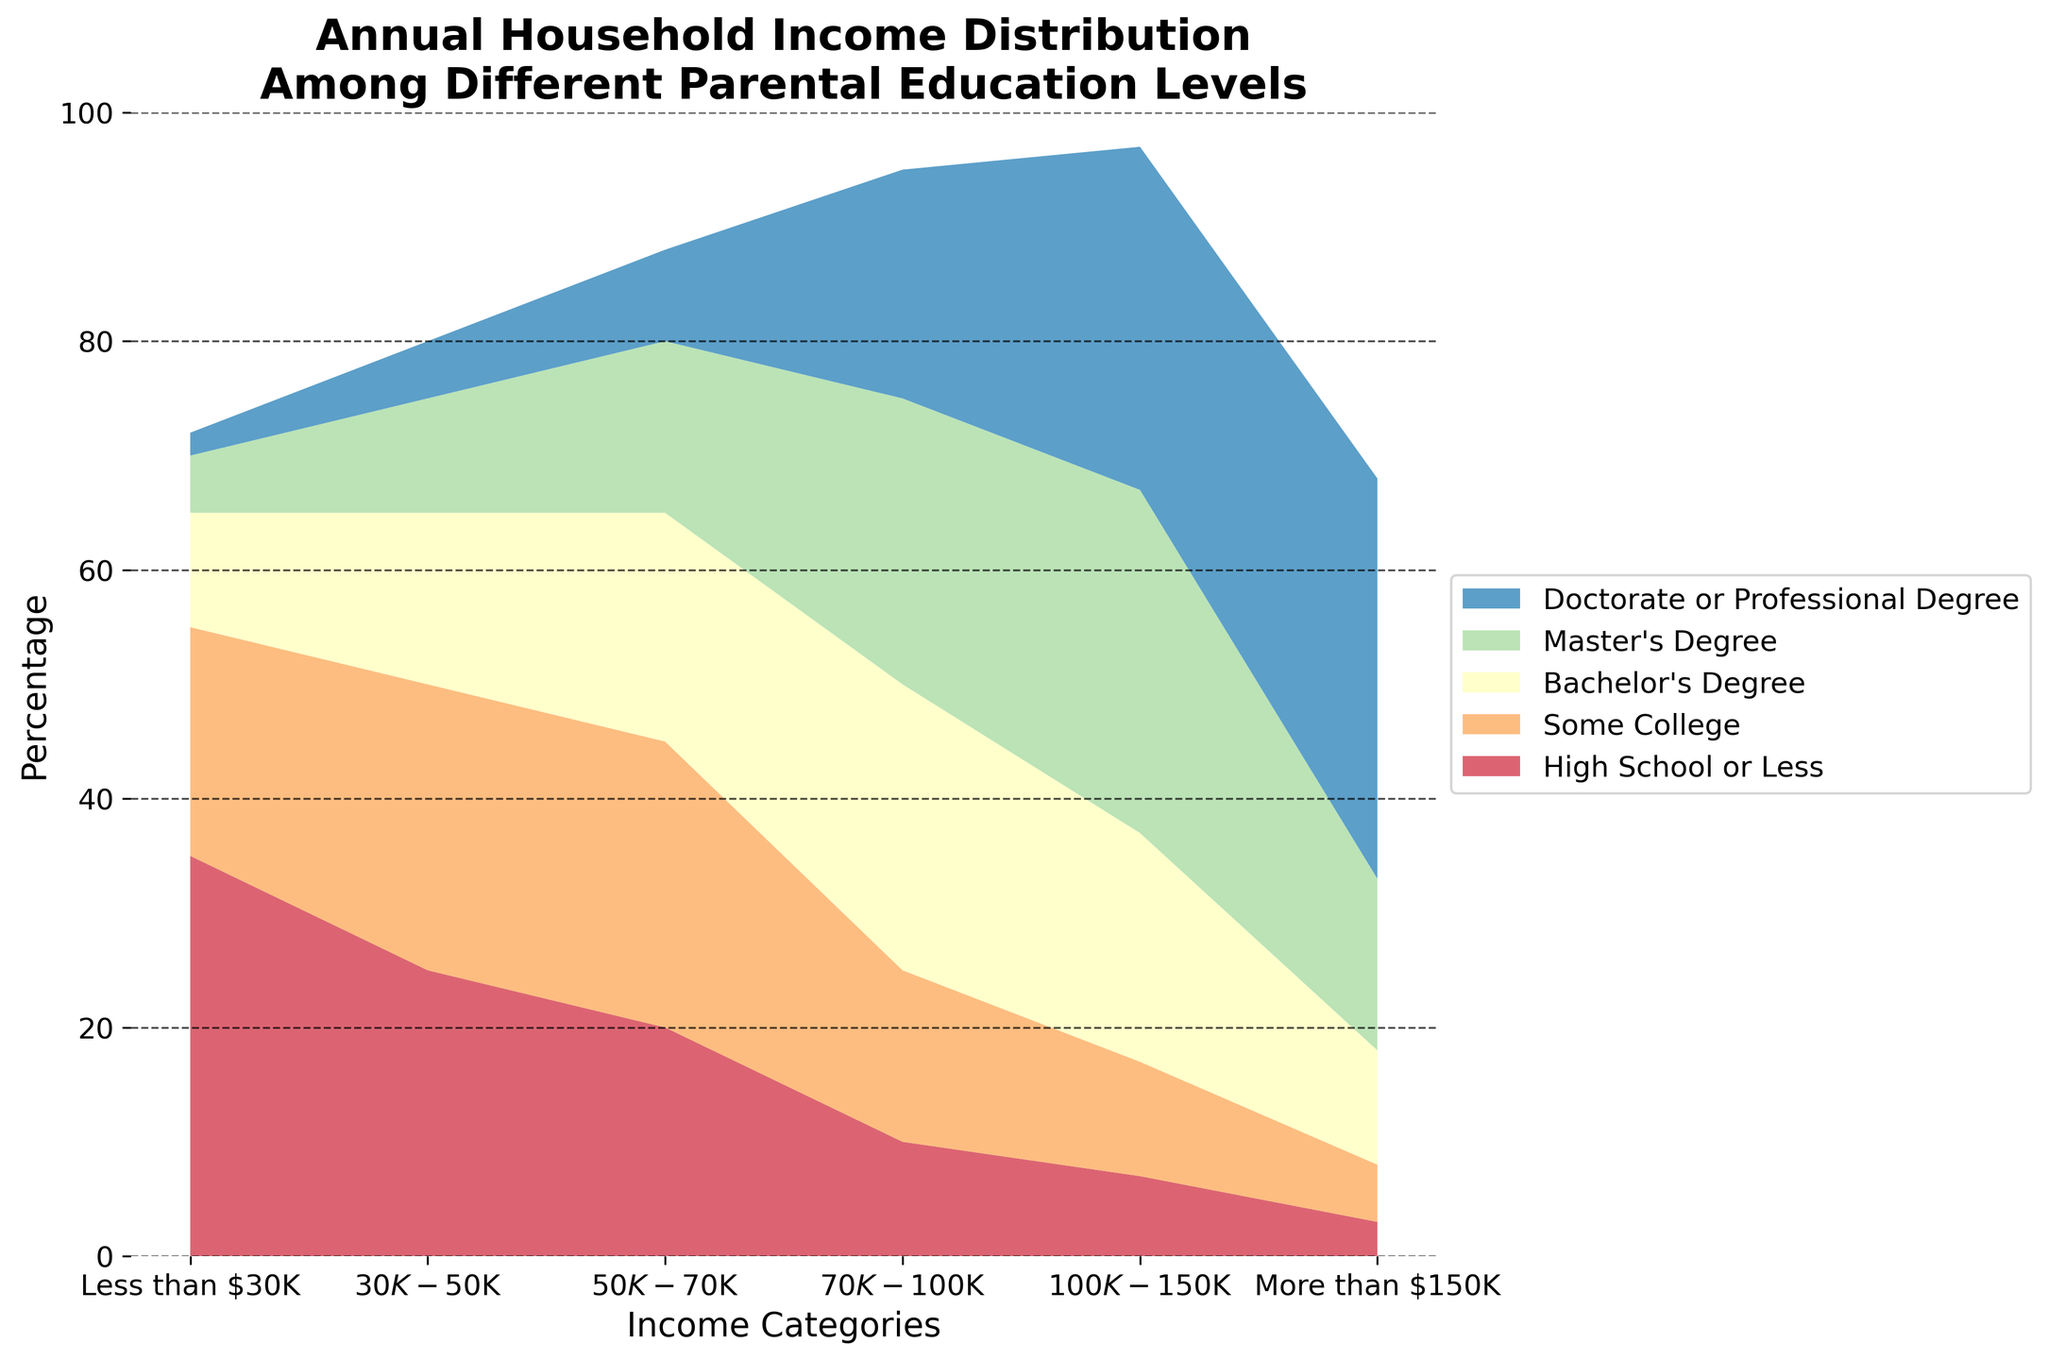What is the title of the figure? The title is usually prominently displayed at the top of the figure.
Answer: Annual Household Income Distribution Among Different Parental Education Levels How many income categories are shown in the figure? By counting the labels on the x-axis, you can determine the number of income categories.
Answer: 6 Which parental education level exhibits the highest percentage for households earning over $150K? The topmost area in the chart for the income category "More than $150K" is the darkest color representing Doctorate or Professional Degree.
Answer: Doctorate or Professional Degree Compare the income distribution for "High School or Less" and "Bachelor's Degree" for households earning between $50K and $100K. Which has a greater percentage? Observing the respective areas for these groups in the income categories $50K-$70K and $70K-$100K. Both areas for High School or Less are lower than those for Bachelor's Degree.
Answer: Bachelor's Degree What percentage of households with a "Master's Degree" earns between $70K and $150K? Add the areas for Master's Degree in $70K-$100K and $100K-$150K. Both segments contribute to the total percentage for this education level within these income ranges.
Answer: 55% Which education level contributes the least to households earning below $30K? The smallest segment in the "Less than $30K" income category represents Doctorate or Professional Degree.
Answer: Doctorate or Professional Degree Summarize the percentage distribution for households with "Some College" education. Adding the individual percentages for "Some College" (20 + 25 + 25 + 15 + 10 + 5) results in a total percentage of 100%.
Answer: 100% How does the percentage of households earning over $150K change as the parental education level increases? Observing the heights of the areas in the "More than $150K" category shows an increasing trend with higher education levels.
Answer: Increases Which education level has the most even distribution of income across all categories? By visually comparing the areas for each education level, "Some College" shows a relatively balanced distribution across all income categories compared to others.
Answer: Some College 